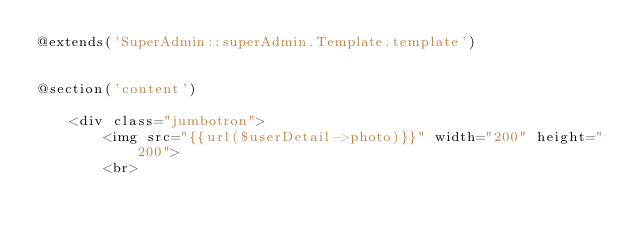<code> <loc_0><loc_0><loc_500><loc_500><_PHP_>@extends('SuperAdmin::superAdmin.Template.template')


@section('content')

    <div class="jumbotron">
        <img src="{{url($userDetail->photo)}}" width="200" height="200">
        <br></code> 